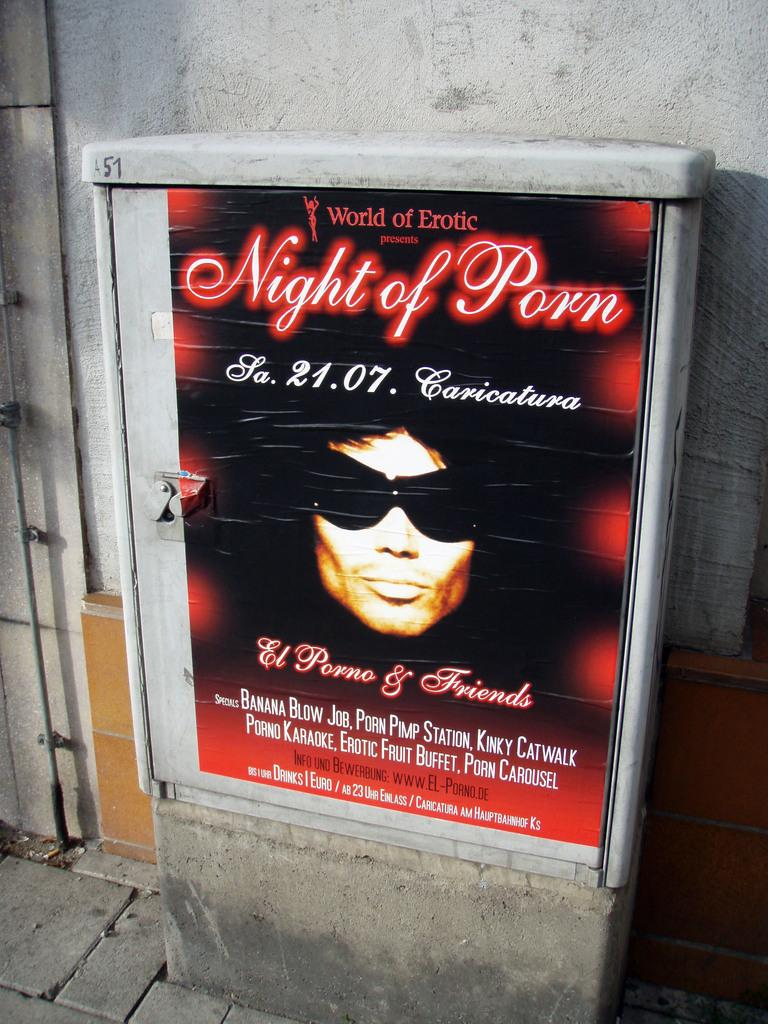<image>
Relay a brief, clear account of the picture shown. an advertisement saying night of porn with someone wearing sunglasses 